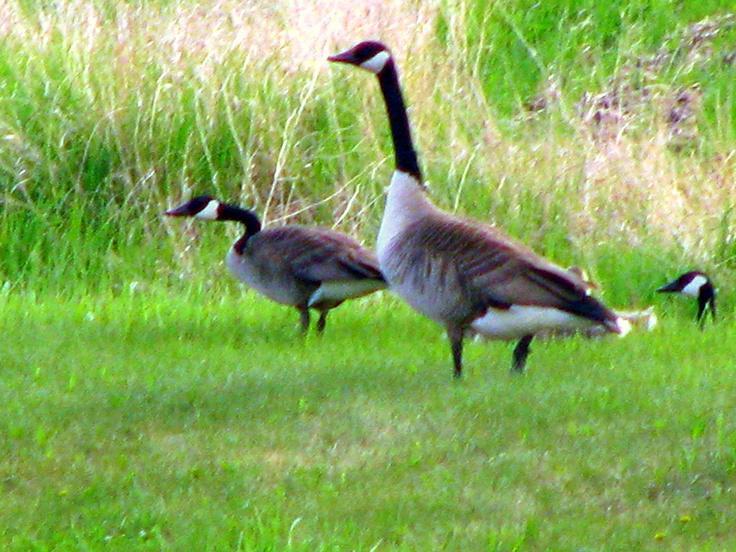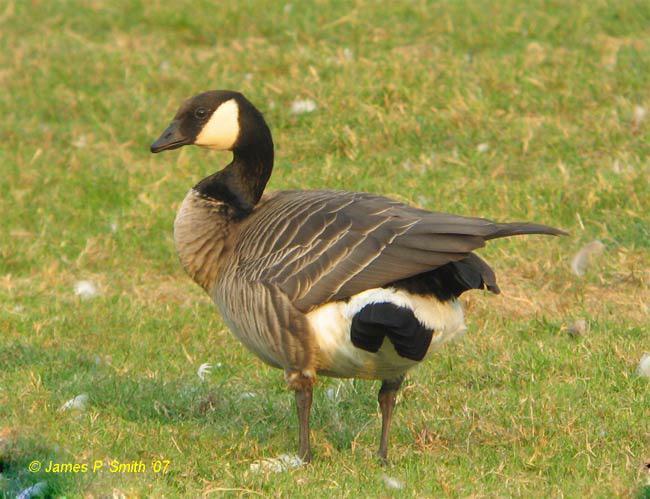The first image is the image on the left, the second image is the image on the right. Assess this claim about the two images: "All geese have black necks, and one image contains at least twice as many geese as the other image.". Correct or not? Answer yes or no. Yes. The first image is the image on the left, the second image is the image on the right. Given the left and right images, does the statement "The right image contains exactly one duck." hold true? Answer yes or no. Yes. 